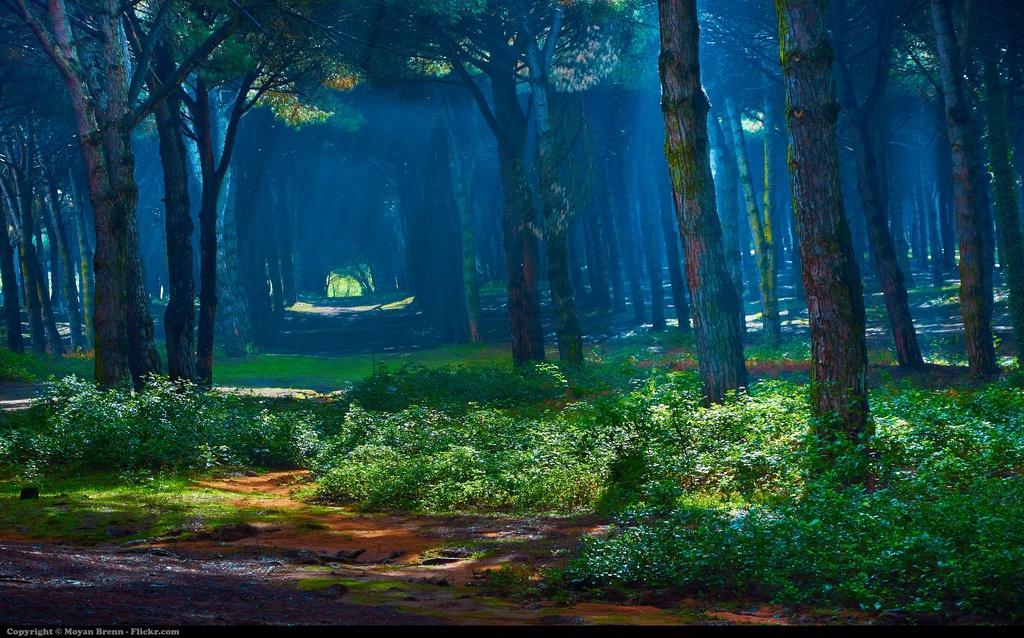In one or two sentences, can you explain what this image depicts? These are the trees with branches and leaves. I can see the plants. At the bottom of the image, I can see the watermark. 